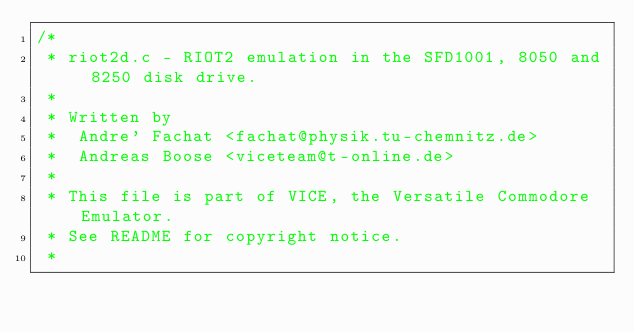Convert code to text. <code><loc_0><loc_0><loc_500><loc_500><_C_>/*
 * riot2d.c - RIOT2 emulation in the SFD1001, 8050 and 8250 disk drive.
 *
 * Written by
 *  Andre' Fachat <fachat@physik.tu-chemnitz.de>
 *  Andreas Boose <viceteam@t-online.de>
 *
 * This file is part of VICE, the Versatile Commodore Emulator.
 * See README for copyright notice.
 *</code> 